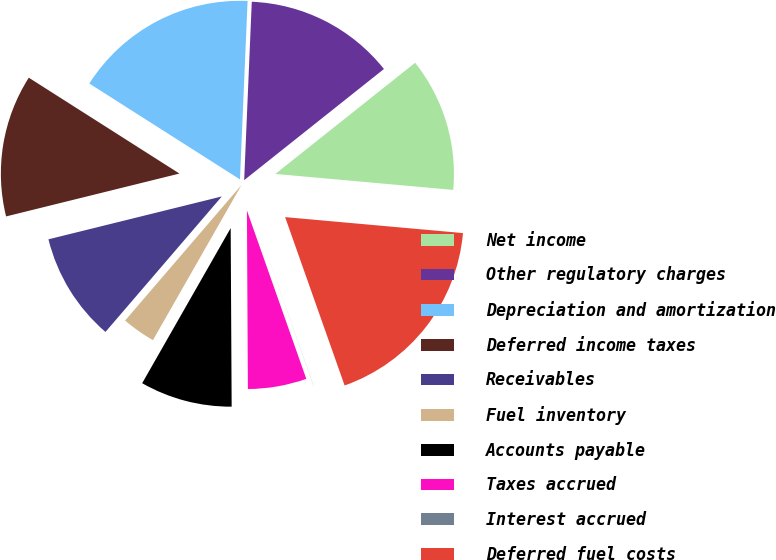Convert chart. <chart><loc_0><loc_0><loc_500><loc_500><pie_chart><fcel>Net income<fcel>Other regulatory charges<fcel>Depreciation and amortization<fcel>Deferred income taxes<fcel>Receivables<fcel>Fuel inventory<fcel>Accounts payable<fcel>Taxes accrued<fcel>Interest accrued<fcel>Deferred fuel costs<nl><fcel>12.12%<fcel>13.63%<fcel>16.66%<fcel>12.88%<fcel>9.85%<fcel>3.04%<fcel>8.34%<fcel>5.31%<fcel>0.01%<fcel>18.17%<nl></chart> 